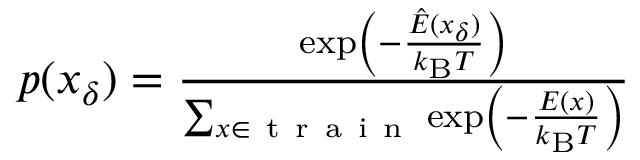<formula> <loc_0><loc_0><loc_500><loc_500>\begin{array} { r } { p ( x _ { \delta } ) = \frac { \exp \left ( - \frac { \hat { E } ( x _ { \delta } ) } { k _ { B } T } \right ) } { \sum _ { x \in t r a i n } \exp \left ( - \frac { E ( x ) } { k _ { B } T } \right ) } } \end{array}</formula> 